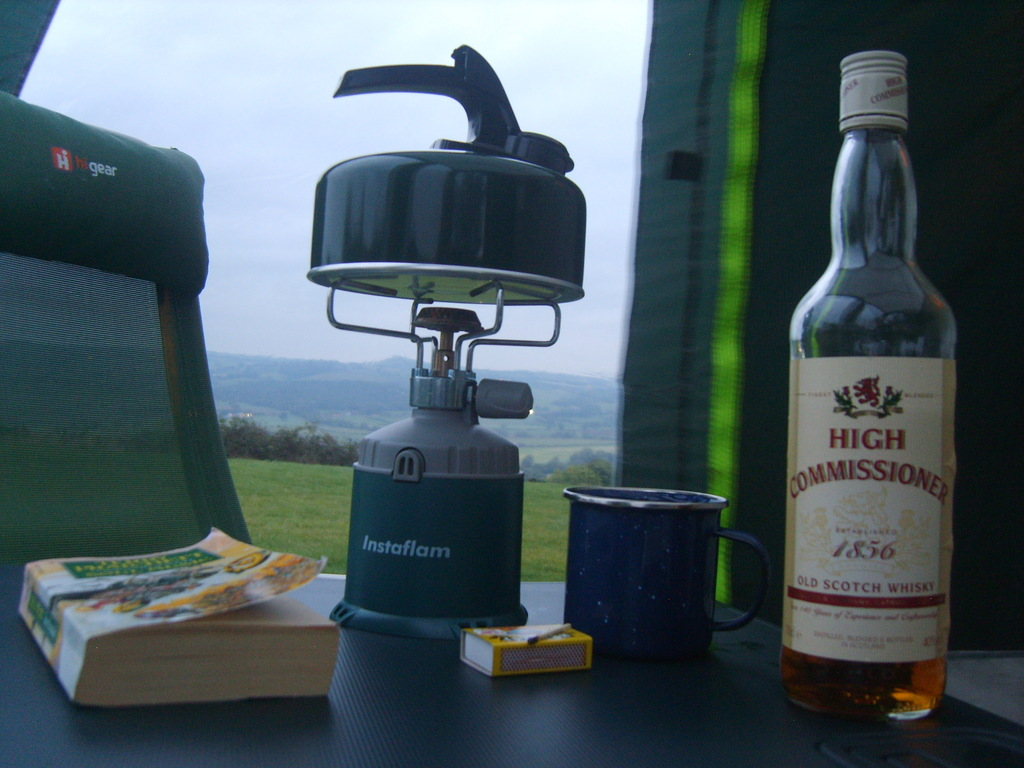Provide a one-sentence caption for the provided image. A cozy camping setup featuring a tea kettle atop an Instaflam burner, accompanied by a bottle of High Commissioner scotch whisky and a novel, with a scenic outdoor backdrop hinting at a relaxing getaway. 